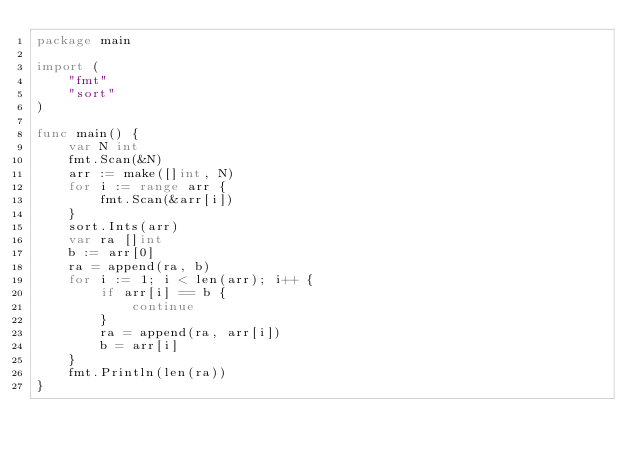Convert code to text. <code><loc_0><loc_0><loc_500><loc_500><_Go_>package main

import (
	"fmt"
	"sort"
)

func main() {
	var N int
	fmt.Scan(&N)
	arr := make([]int, N)
	for i := range arr {
		fmt.Scan(&arr[i])
	}
	sort.Ints(arr)
	var ra []int
	b := arr[0]
	ra = append(ra, b)
	for i := 1; i < len(arr); i++ {
		if arr[i] == b {
			continue
		}
		ra = append(ra, arr[i])
		b = arr[i]
	}
	fmt.Println(len(ra))
}
</code> 